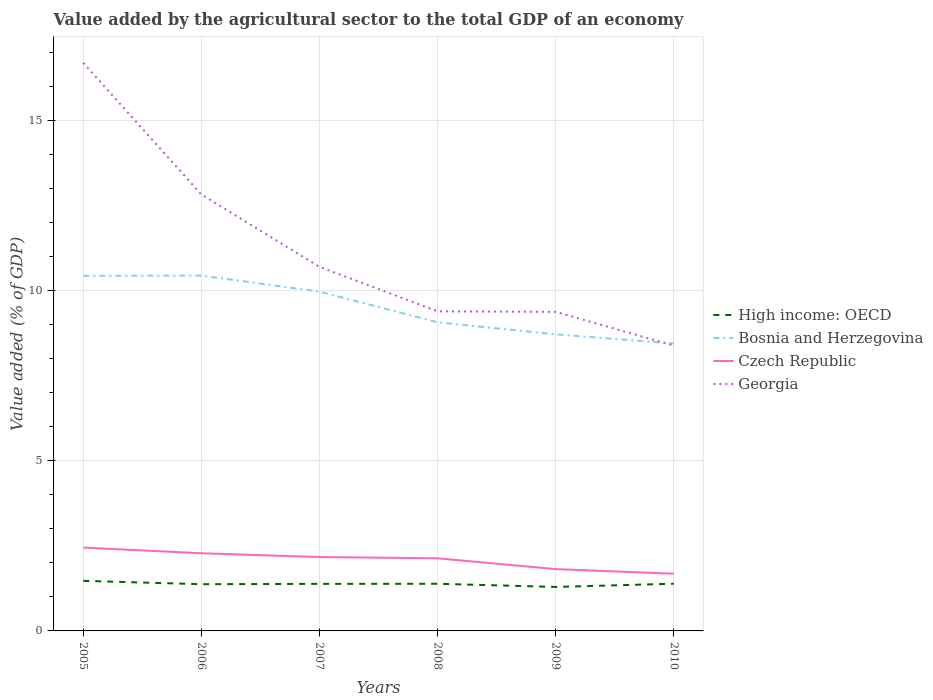Is the number of lines equal to the number of legend labels?
Offer a very short reply. Yes. Across all years, what is the maximum value added by the agricultural sector to the total GDP in Bosnia and Herzegovina?
Offer a terse response. 8.44. What is the total value added by the agricultural sector to the total GDP in Bosnia and Herzegovina in the graph?
Your answer should be compact. 1.72. What is the difference between the highest and the second highest value added by the agricultural sector to the total GDP in High income: OECD?
Your answer should be compact. 0.18. What is the difference between the highest and the lowest value added by the agricultural sector to the total GDP in Czech Republic?
Your answer should be compact. 4. Is the value added by the agricultural sector to the total GDP in Bosnia and Herzegovina strictly greater than the value added by the agricultural sector to the total GDP in Czech Republic over the years?
Your response must be concise. No. How many lines are there?
Provide a succinct answer. 4. What is the difference between two consecutive major ticks on the Y-axis?
Provide a short and direct response. 5. Does the graph contain any zero values?
Your answer should be compact. No. Where does the legend appear in the graph?
Your answer should be very brief. Center right. How many legend labels are there?
Your answer should be very brief. 4. What is the title of the graph?
Ensure brevity in your answer.  Value added by the agricultural sector to the total GDP of an economy. Does "Macedonia" appear as one of the legend labels in the graph?
Ensure brevity in your answer.  No. What is the label or title of the X-axis?
Make the answer very short. Years. What is the label or title of the Y-axis?
Provide a short and direct response. Value added (% of GDP). What is the Value added (% of GDP) in High income: OECD in 2005?
Your response must be concise. 1.47. What is the Value added (% of GDP) of Bosnia and Herzegovina in 2005?
Ensure brevity in your answer.  10.43. What is the Value added (% of GDP) of Czech Republic in 2005?
Your response must be concise. 2.45. What is the Value added (% of GDP) of Georgia in 2005?
Provide a succinct answer. 16.69. What is the Value added (% of GDP) in High income: OECD in 2006?
Your answer should be very brief. 1.37. What is the Value added (% of GDP) of Bosnia and Herzegovina in 2006?
Keep it short and to the point. 10.44. What is the Value added (% of GDP) of Czech Republic in 2006?
Your response must be concise. 2.28. What is the Value added (% of GDP) of Georgia in 2006?
Your answer should be compact. 12.82. What is the Value added (% of GDP) in High income: OECD in 2007?
Keep it short and to the point. 1.38. What is the Value added (% of GDP) in Bosnia and Herzegovina in 2007?
Ensure brevity in your answer.  9.97. What is the Value added (% of GDP) of Czech Republic in 2007?
Offer a terse response. 2.17. What is the Value added (% of GDP) in Georgia in 2007?
Provide a short and direct response. 10.7. What is the Value added (% of GDP) in High income: OECD in 2008?
Offer a terse response. 1.39. What is the Value added (% of GDP) of Bosnia and Herzegovina in 2008?
Provide a succinct answer. 9.07. What is the Value added (% of GDP) in Czech Republic in 2008?
Ensure brevity in your answer.  2.13. What is the Value added (% of GDP) of Georgia in 2008?
Provide a short and direct response. 9.39. What is the Value added (% of GDP) in High income: OECD in 2009?
Keep it short and to the point. 1.29. What is the Value added (% of GDP) of Bosnia and Herzegovina in 2009?
Your answer should be compact. 8.71. What is the Value added (% of GDP) of Czech Republic in 2009?
Offer a very short reply. 1.82. What is the Value added (% of GDP) of Georgia in 2009?
Offer a terse response. 9.37. What is the Value added (% of GDP) of High income: OECD in 2010?
Your answer should be very brief. 1.39. What is the Value added (% of GDP) of Bosnia and Herzegovina in 2010?
Your answer should be compact. 8.44. What is the Value added (% of GDP) of Czech Republic in 2010?
Your response must be concise. 1.68. What is the Value added (% of GDP) of Georgia in 2010?
Offer a terse response. 8.38. Across all years, what is the maximum Value added (% of GDP) in High income: OECD?
Ensure brevity in your answer.  1.47. Across all years, what is the maximum Value added (% of GDP) in Bosnia and Herzegovina?
Keep it short and to the point. 10.44. Across all years, what is the maximum Value added (% of GDP) of Czech Republic?
Offer a terse response. 2.45. Across all years, what is the maximum Value added (% of GDP) in Georgia?
Keep it short and to the point. 16.69. Across all years, what is the minimum Value added (% of GDP) of High income: OECD?
Your answer should be very brief. 1.29. Across all years, what is the minimum Value added (% of GDP) in Bosnia and Herzegovina?
Your answer should be compact. 8.44. Across all years, what is the minimum Value added (% of GDP) in Czech Republic?
Your answer should be compact. 1.68. Across all years, what is the minimum Value added (% of GDP) of Georgia?
Offer a terse response. 8.38. What is the total Value added (% of GDP) of High income: OECD in the graph?
Provide a short and direct response. 8.29. What is the total Value added (% of GDP) of Bosnia and Herzegovina in the graph?
Make the answer very short. 57.06. What is the total Value added (% of GDP) in Czech Republic in the graph?
Ensure brevity in your answer.  12.53. What is the total Value added (% of GDP) in Georgia in the graph?
Provide a succinct answer. 67.35. What is the difference between the Value added (% of GDP) in High income: OECD in 2005 and that in 2006?
Offer a very short reply. 0.1. What is the difference between the Value added (% of GDP) in Bosnia and Herzegovina in 2005 and that in 2006?
Make the answer very short. -0.01. What is the difference between the Value added (% of GDP) of Czech Republic in 2005 and that in 2006?
Your answer should be very brief. 0.17. What is the difference between the Value added (% of GDP) of Georgia in 2005 and that in 2006?
Your response must be concise. 3.87. What is the difference between the Value added (% of GDP) of High income: OECD in 2005 and that in 2007?
Provide a short and direct response. 0.09. What is the difference between the Value added (% of GDP) of Bosnia and Herzegovina in 2005 and that in 2007?
Offer a very short reply. 0.46. What is the difference between the Value added (% of GDP) in Czech Republic in 2005 and that in 2007?
Give a very brief answer. 0.28. What is the difference between the Value added (% of GDP) of Georgia in 2005 and that in 2007?
Ensure brevity in your answer.  5.99. What is the difference between the Value added (% of GDP) of High income: OECD in 2005 and that in 2008?
Your answer should be compact. 0.09. What is the difference between the Value added (% of GDP) of Bosnia and Herzegovina in 2005 and that in 2008?
Provide a succinct answer. 1.36. What is the difference between the Value added (% of GDP) of Czech Republic in 2005 and that in 2008?
Your answer should be very brief. 0.31. What is the difference between the Value added (% of GDP) of Georgia in 2005 and that in 2008?
Ensure brevity in your answer.  7.3. What is the difference between the Value added (% of GDP) in High income: OECD in 2005 and that in 2009?
Offer a terse response. 0.18. What is the difference between the Value added (% of GDP) in Bosnia and Herzegovina in 2005 and that in 2009?
Provide a succinct answer. 1.72. What is the difference between the Value added (% of GDP) of Czech Republic in 2005 and that in 2009?
Keep it short and to the point. 0.63. What is the difference between the Value added (% of GDP) of Georgia in 2005 and that in 2009?
Make the answer very short. 7.32. What is the difference between the Value added (% of GDP) of High income: OECD in 2005 and that in 2010?
Keep it short and to the point. 0.08. What is the difference between the Value added (% of GDP) of Bosnia and Herzegovina in 2005 and that in 2010?
Make the answer very short. 1.99. What is the difference between the Value added (% of GDP) of Czech Republic in 2005 and that in 2010?
Offer a very short reply. 0.77. What is the difference between the Value added (% of GDP) of Georgia in 2005 and that in 2010?
Make the answer very short. 8.31. What is the difference between the Value added (% of GDP) in High income: OECD in 2006 and that in 2007?
Make the answer very short. -0.01. What is the difference between the Value added (% of GDP) in Bosnia and Herzegovina in 2006 and that in 2007?
Offer a terse response. 0.47. What is the difference between the Value added (% of GDP) in Czech Republic in 2006 and that in 2007?
Ensure brevity in your answer.  0.11. What is the difference between the Value added (% of GDP) in Georgia in 2006 and that in 2007?
Make the answer very short. 2.12. What is the difference between the Value added (% of GDP) of High income: OECD in 2006 and that in 2008?
Provide a succinct answer. -0.01. What is the difference between the Value added (% of GDP) in Bosnia and Herzegovina in 2006 and that in 2008?
Keep it short and to the point. 1.37. What is the difference between the Value added (% of GDP) in Czech Republic in 2006 and that in 2008?
Keep it short and to the point. 0.15. What is the difference between the Value added (% of GDP) of Georgia in 2006 and that in 2008?
Your answer should be compact. 3.43. What is the difference between the Value added (% of GDP) in High income: OECD in 2006 and that in 2009?
Provide a short and direct response. 0.08. What is the difference between the Value added (% of GDP) in Bosnia and Herzegovina in 2006 and that in 2009?
Ensure brevity in your answer.  1.73. What is the difference between the Value added (% of GDP) of Czech Republic in 2006 and that in 2009?
Your answer should be very brief. 0.47. What is the difference between the Value added (% of GDP) in Georgia in 2006 and that in 2009?
Your response must be concise. 3.45. What is the difference between the Value added (% of GDP) in High income: OECD in 2006 and that in 2010?
Provide a succinct answer. -0.01. What is the difference between the Value added (% of GDP) of Bosnia and Herzegovina in 2006 and that in 2010?
Your response must be concise. 2. What is the difference between the Value added (% of GDP) of Czech Republic in 2006 and that in 2010?
Keep it short and to the point. 0.6. What is the difference between the Value added (% of GDP) of Georgia in 2006 and that in 2010?
Your answer should be very brief. 4.44. What is the difference between the Value added (% of GDP) in High income: OECD in 2007 and that in 2008?
Make the answer very short. -0. What is the difference between the Value added (% of GDP) in Bosnia and Herzegovina in 2007 and that in 2008?
Your response must be concise. 0.9. What is the difference between the Value added (% of GDP) of Czech Republic in 2007 and that in 2008?
Your answer should be very brief. 0.04. What is the difference between the Value added (% of GDP) of Georgia in 2007 and that in 2008?
Provide a short and direct response. 1.31. What is the difference between the Value added (% of GDP) of High income: OECD in 2007 and that in 2009?
Provide a succinct answer. 0.09. What is the difference between the Value added (% of GDP) in Bosnia and Herzegovina in 2007 and that in 2009?
Keep it short and to the point. 1.26. What is the difference between the Value added (% of GDP) of Czech Republic in 2007 and that in 2009?
Make the answer very short. 0.35. What is the difference between the Value added (% of GDP) of Georgia in 2007 and that in 2009?
Make the answer very short. 1.32. What is the difference between the Value added (% of GDP) in High income: OECD in 2007 and that in 2010?
Your answer should be very brief. -0. What is the difference between the Value added (% of GDP) of Bosnia and Herzegovina in 2007 and that in 2010?
Offer a very short reply. 1.52. What is the difference between the Value added (% of GDP) of Czech Republic in 2007 and that in 2010?
Your answer should be very brief. 0.49. What is the difference between the Value added (% of GDP) in Georgia in 2007 and that in 2010?
Offer a very short reply. 2.31. What is the difference between the Value added (% of GDP) of High income: OECD in 2008 and that in 2009?
Give a very brief answer. 0.09. What is the difference between the Value added (% of GDP) in Bosnia and Herzegovina in 2008 and that in 2009?
Your answer should be compact. 0.35. What is the difference between the Value added (% of GDP) of Czech Republic in 2008 and that in 2009?
Keep it short and to the point. 0.32. What is the difference between the Value added (% of GDP) of Georgia in 2008 and that in 2009?
Offer a very short reply. 0.02. What is the difference between the Value added (% of GDP) in High income: OECD in 2008 and that in 2010?
Provide a succinct answer. -0. What is the difference between the Value added (% of GDP) of Bosnia and Herzegovina in 2008 and that in 2010?
Provide a succinct answer. 0.62. What is the difference between the Value added (% of GDP) of Czech Republic in 2008 and that in 2010?
Provide a short and direct response. 0.45. What is the difference between the Value added (% of GDP) in High income: OECD in 2009 and that in 2010?
Your answer should be very brief. -0.09. What is the difference between the Value added (% of GDP) in Bosnia and Herzegovina in 2009 and that in 2010?
Your response must be concise. 0.27. What is the difference between the Value added (% of GDP) of Czech Republic in 2009 and that in 2010?
Ensure brevity in your answer.  0.14. What is the difference between the Value added (% of GDP) in Georgia in 2009 and that in 2010?
Ensure brevity in your answer.  0.99. What is the difference between the Value added (% of GDP) in High income: OECD in 2005 and the Value added (% of GDP) in Bosnia and Herzegovina in 2006?
Your answer should be very brief. -8.97. What is the difference between the Value added (% of GDP) in High income: OECD in 2005 and the Value added (% of GDP) in Czech Republic in 2006?
Ensure brevity in your answer.  -0.81. What is the difference between the Value added (% of GDP) of High income: OECD in 2005 and the Value added (% of GDP) of Georgia in 2006?
Provide a short and direct response. -11.35. What is the difference between the Value added (% of GDP) in Bosnia and Herzegovina in 2005 and the Value added (% of GDP) in Czech Republic in 2006?
Make the answer very short. 8.15. What is the difference between the Value added (% of GDP) of Bosnia and Herzegovina in 2005 and the Value added (% of GDP) of Georgia in 2006?
Offer a terse response. -2.39. What is the difference between the Value added (% of GDP) of Czech Republic in 2005 and the Value added (% of GDP) of Georgia in 2006?
Give a very brief answer. -10.37. What is the difference between the Value added (% of GDP) in High income: OECD in 2005 and the Value added (% of GDP) in Bosnia and Herzegovina in 2007?
Your answer should be compact. -8.5. What is the difference between the Value added (% of GDP) in High income: OECD in 2005 and the Value added (% of GDP) in Czech Republic in 2007?
Offer a very short reply. -0.7. What is the difference between the Value added (% of GDP) in High income: OECD in 2005 and the Value added (% of GDP) in Georgia in 2007?
Provide a short and direct response. -9.22. What is the difference between the Value added (% of GDP) of Bosnia and Herzegovina in 2005 and the Value added (% of GDP) of Czech Republic in 2007?
Keep it short and to the point. 8.26. What is the difference between the Value added (% of GDP) of Bosnia and Herzegovina in 2005 and the Value added (% of GDP) of Georgia in 2007?
Provide a succinct answer. -0.26. What is the difference between the Value added (% of GDP) of Czech Republic in 2005 and the Value added (% of GDP) of Georgia in 2007?
Provide a succinct answer. -8.25. What is the difference between the Value added (% of GDP) in High income: OECD in 2005 and the Value added (% of GDP) in Bosnia and Herzegovina in 2008?
Offer a very short reply. -7.59. What is the difference between the Value added (% of GDP) in High income: OECD in 2005 and the Value added (% of GDP) in Czech Republic in 2008?
Keep it short and to the point. -0.66. What is the difference between the Value added (% of GDP) of High income: OECD in 2005 and the Value added (% of GDP) of Georgia in 2008?
Your answer should be compact. -7.92. What is the difference between the Value added (% of GDP) of Bosnia and Herzegovina in 2005 and the Value added (% of GDP) of Czech Republic in 2008?
Provide a short and direct response. 8.3. What is the difference between the Value added (% of GDP) of Bosnia and Herzegovina in 2005 and the Value added (% of GDP) of Georgia in 2008?
Your answer should be very brief. 1.04. What is the difference between the Value added (% of GDP) of Czech Republic in 2005 and the Value added (% of GDP) of Georgia in 2008?
Your answer should be very brief. -6.94. What is the difference between the Value added (% of GDP) of High income: OECD in 2005 and the Value added (% of GDP) of Bosnia and Herzegovina in 2009?
Your answer should be compact. -7.24. What is the difference between the Value added (% of GDP) in High income: OECD in 2005 and the Value added (% of GDP) in Czech Republic in 2009?
Offer a very short reply. -0.34. What is the difference between the Value added (% of GDP) of High income: OECD in 2005 and the Value added (% of GDP) of Georgia in 2009?
Offer a very short reply. -7.9. What is the difference between the Value added (% of GDP) in Bosnia and Herzegovina in 2005 and the Value added (% of GDP) in Czech Republic in 2009?
Your response must be concise. 8.61. What is the difference between the Value added (% of GDP) of Bosnia and Herzegovina in 2005 and the Value added (% of GDP) of Georgia in 2009?
Provide a short and direct response. 1.06. What is the difference between the Value added (% of GDP) of Czech Republic in 2005 and the Value added (% of GDP) of Georgia in 2009?
Offer a terse response. -6.92. What is the difference between the Value added (% of GDP) in High income: OECD in 2005 and the Value added (% of GDP) in Bosnia and Herzegovina in 2010?
Your answer should be compact. -6.97. What is the difference between the Value added (% of GDP) in High income: OECD in 2005 and the Value added (% of GDP) in Czech Republic in 2010?
Provide a succinct answer. -0.21. What is the difference between the Value added (% of GDP) of High income: OECD in 2005 and the Value added (% of GDP) of Georgia in 2010?
Offer a very short reply. -6.91. What is the difference between the Value added (% of GDP) of Bosnia and Herzegovina in 2005 and the Value added (% of GDP) of Czech Republic in 2010?
Your answer should be compact. 8.75. What is the difference between the Value added (% of GDP) in Bosnia and Herzegovina in 2005 and the Value added (% of GDP) in Georgia in 2010?
Ensure brevity in your answer.  2.05. What is the difference between the Value added (% of GDP) in Czech Republic in 2005 and the Value added (% of GDP) in Georgia in 2010?
Ensure brevity in your answer.  -5.93. What is the difference between the Value added (% of GDP) of High income: OECD in 2006 and the Value added (% of GDP) of Bosnia and Herzegovina in 2007?
Your answer should be very brief. -8.59. What is the difference between the Value added (% of GDP) of High income: OECD in 2006 and the Value added (% of GDP) of Czech Republic in 2007?
Offer a terse response. -0.8. What is the difference between the Value added (% of GDP) in High income: OECD in 2006 and the Value added (% of GDP) in Georgia in 2007?
Your answer should be very brief. -9.32. What is the difference between the Value added (% of GDP) of Bosnia and Herzegovina in 2006 and the Value added (% of GDP) of Czech Republic in 2007?
Offer a terse response. 8.27. What is the difference between the Value added (% of GDP) of Bosnia and Herzegovina in 2006 and the Value added (% of GDP) of Georgia in 2007?
Ensure brevity in your answer.  -0.26. What is the difference between the Value added (% of GDP) in Czech Republic in 2006 and the Value added (% of GDP) in Georgia in 2007?
Offer a very short reply. -8.41. What is the difference between the Value added (% of GDP) of High income: OECD in 2006 and the Value added (% of GDP) of Bosnia and Herzegovina in 2008?
Offer a very short reply. -7.69. What is the difference between the Value added (% of GDP) of High income: OECD in 2006 and the Value added (% of GDP) of Czech Republic in 2008?
Make the answer very short. -0.76. What is the difference between the Value added (% of GDP) of High income: OECD in 2006 and the Value added (% of GDP) of Georgia in 2008?
Provide a short and direct response. -8.02. What is the difference between the Value added (% of GDP) of Bosnia and Herzegovina in 2006 and the Value added (% of GDP) of Czech Republic in 2008?
Offer a terse response. 8.31. What is the difference between the Value added (% of GDP) in Bosnia and Herzegovina in 2006 and the Value added (% of GDP) in Georgia in 2008?
Give a very brief answer. 1.05. What is the difference between the Value added (% of GDP) in Czech Republic in 2006 and the Value added (% of GDP) in Georgia in 2008?
Make the answer very short. -7.11. What is the difference between the Value added (% of GDP) of High income: OECD in 2006 and the Value added (% of GDP) of Bosnia and Herzegovina in 2009?
Your answer should be compact. -7.34. What is the difference between the Value added (% of GDP) in High income: OECD in 2006 and the Value added (% of GDP) in Czech Republic in 2009?
Offer a very short reply. -0.44. What is the difference between the Value added (% of GDP) of High income: OECD in 2006 and the Value added (% of GDP) of Georgia in 2009?
Make the answer very short. -8. What is the difference between the Value added (% of GDP) of Bosnia and Herzegovina in 2006 and the Value added (% of GDP) of Czech Republic in 2009?
Your response must be concise. 8.62. What is the difference between the Value added (% of GDP) in Bosnia and Herzegovina in 2006 and the Value added (% of GDP) in Georgia in 2009?
Your answer should be very brief. 1.07. What is the difference between the Value added (% of GDP) in Czech Republic in 2006 and the Value added (% of GDP) in Georgia in 2009?
Your response must be concise. -7.09. What is the difference between the Value added (% of GDP) in High income: OECD in 2006 and the Value added (% of GDP) in Bosnia and Herzegovina in 2010?
Your response must be concise. -7.07. What is the difference between the Value added (% of GDP) of High income: OECD in 2006 and the Value added (% of GDP) of Czech Republic in 2010?
Ensure brevity in your answer.  -0.31. What is the difference between the Value added (% of GDP) of High income: OECD in 2006 and the Value added (% of GDP) of Georgia in 2010?
Give a very brief answer. -7.01. What is the difference between the Value added (% of GDP) in Bosnia and Herzegovina in 2006 and the Value added (% of GDP) in Czech Republic in 2010?
Ensure brevity in your answer.  8.76. What is the difference between the Value added (% of GDP) in Bosnia and Herzegovina in 2006 and the Value added (% of GDP) in Georgia in 2010?
Ensure brevity in your answer.  2.06. What is the difference between the Value added (% of GDP) of Czech Republic in 2006 and the Value added (% of GDP) of Georgia in 2010?
Provide a short and direct response. -6.1. What is the difference between the Value added (% of GDP) of High income: OECD in 2007 and the Value added (% of GDP) of Bosnia and Herzegovina in 2008?
Provide a short and direct response. -7.68. What is the difference between the Value added (% of GDP) of High income: OECD in 2007 and the Value added (% of GDP) of Czech Republic in 2008?
Provide a succinct answer. -0.75. What is the difference between the Value added (% of GDP) of High income: OECD in 2007 and the Value added (% of GDP) of Georgia in 2008?
Your answer should be very brief. -8.01. What is the difference between the Value added (% of GDP) of Bosnia and Herzegovina in 2007 and the Value added (% of GDP) of Czech Republic in 2008?
Offer a very short reply. 7.83. What is the difference between the Value added (% of GDP) of Bosnia and Herzegovina in 2007 and the Value added (% of GDP) of Georgia in 2008?
Your answer should be compact. 0.58. What is the difference between the Value added (% of GDP) in Czech Republic in 2007 and the Value added (% of GDP) in Georgia in 2008?
Provide a short and direct response. -7.22. What is the difference between the Value added (% of GDP) of High income: OECD in 2007 and the Value added (% of GDP) of Bosnia and Herzegovina in 2009?
Ensure brevity in your answer.  -7.33. What is the difference between the Value added (% of GDP) in High income: OECD in 2007 and the Value added (% of GDP) in Czech Republic in 2009?
Your response must be concise. -0.43. What is the difference between the Value added (% of GDP) in High income: OECD in 2007 and the Value added (% of GDP) in Georgia in 2009?
Offer a very short reply. -7.99. What is the difference between the Value added (% of GDP) in Bosnia and Herzegovina in 2007 and the Value added (% of GDP) in Czech Republic in 2009?
Ensure brevity in your answer.  8.15. What is the difference between the Value added (% of GDP) of Bosnia and Herzegovina in 2007 and the Value added (% of GDP) of Georgia in 2009?
Make the answer very short. 0.59. What is the difference between the Value added (% of GDP) in Czech Republic in 2007 and the Value added (% of GDP) in Georgia in 2009?
Offer a terse response. -7.2. What is the difference between the Value added (% of GDP) of High income: OECD in 2007 and the Value added (% of GDP) of Bosnia and Herzegovina in 2010?
Make the answer very short. -7.06. What is the difference between the Value added (% of GDP) of High income: OECD in 2007 and the Value added (% of GDP) of Czech Republic in 2010?
Provide a short and direct response. -0.3. What is the difference between the Value added (% of GDP) in High income: OECD in 2007 and the Value added (% of GDP) in Georgia in 2010?
Your answer should be compact. -7. What is the difference between the Value added (% of GDP) of Bosnia and Herzegovina in 2007 and the Value added (% of GDP) of Czech Republic in 2010?
Make the answer very short. 8.29. What is the difference between the Value added (% of GDP) in Bosnia and Herzegovina in 2007 and the Value added (% of GDP) in Georgia in 2010?
Provide a succinct answer. 1.59. What is the difference between the Value added (% of GDP) of Czech Republic in 2007 and the Value added (% of GDP) of Georgia in 2010?
Make the answer very short. -6.21. What is the difference between the Value added (% of GDP) of High income: OECD in 2008 and the Value added (% of GDP) of Bosnia and Herzegovina in 2009?
Make the answer very short. -7.33. What is the difference between the Value added (% of GDP) in High income: OECD in 2008 and the Value added (% of GDP) in Czech Republic in 2009?
Ensure brevity in your answer.  -0.43. What is the difference between the Value added (% of GDP) of High income: OECD in 2008 and the Value added (% of GDP) of Georgia in 2009?
Your answer should be compact. -7.99. What is the difference between the Value added (% of GDP) of Bosnia and Herzegovina in 2008 and the Value added (% of GDP) of Czech Republic in 2009?
Offer a very short reply. 7.25. What is the difference between the Value added (% of GDP) of Bosnia and Herzegovina in 2008 and the Value added (% of GDP) of Georgia in 2009?
Provide a succinct answer. -0.31. What is the difference between the Value added (% of GDP) in Czech Republic in 2008 and the Value added (% of GDP) in Georgia in 2009?
Keep it short and to the point. -7.24. What is the difference between the Value added (% of GDP) in High income: OECD in 2008 and the Value added (% of GDP) in Bosnia and Herzegovina in 2010?
Offer a very short reply. -7.06. What is the difference between the Value added (% of GDP) in High income: OECD in 2008 and the Value added (% of GDP) in Czech Republic in 2010?
Provide a succinct answer. -0.3. What is the difference between the Value added (% of GDP) of High income: OECD in 2008 and the Value added (% of GDP) of Georgia in 2010?
Give a very brief answer. -7. What is the difference between the Value added (% of GDP) in Bosnia and Herzegovina in 2008 and the Value added (% of GDP) in Czech Republic in 2010?
Provide a short and direct response. 7.39. What is the difference between the Value added (% of GDP) of Bosnia and Herzegovina in 2008 and the Value added (% of GDP) of Georgia in 2010?
Offer a very short reply. 0.68. What is the difference between the Value added (% of GDP) of Czech Republic in 2008 and the Value added (% of GDP) of Georgia in 2010?
Your response must be concise. -6.25. What is the difference between the Value added (% of GDP) in High income: OECD in 2009 and the Value added (% of GDP) in Bosnia and Herzegovina in 2010?
Your response must be concise. -7.15. What is the difference between the Value added (% of GDP) in High income: OECD in 2009 and the Value added (% of GDP) in Czech Republic in 2010?
Make the answer very short. -0.39. What is the difference between the Value added (% of GDP) in High income: OECD in 2009 and the Value added (% of GDP) in Georgia in 2010?
Your answer should be compact. -7.09. What is the difference between the Value added (% of GDP) of Bosnia and Herzegovina in 2009 and the Value added (% of GDP) of Czech Republic in 2010?
Your answer should be compact. 7.03. What is the difference between the Value added (% of GDP) in Bosnia and Herzegovina in 2009 and the Value added (% of GDP) in Georgia in 2010?
Your answer should be compact. 0.33. What is the difference between the Value added (% of GDP) in Czech Republic in 2009 and the Value added (% of GDP) in Georgia in 2010?
Provide a short and direct response. -6.57. What is the average Value added (% of GDP) in High income: OECD per year?
Offer a terse response. 1.38. What is the average Value added (% of GDP) in Bosnia and Herzegovina per year?
Offer a very short reply. 9.51. What is the average Value added (% of GDP) of Czech Republic per year?
Your response must be concise. 2.09. What is the average Value added (% of GDP) in Georgia per year?
Your answer should be compact. 11.22. In the year 2005, what is the difference between the Value added (% of GDP) in High income: OECD and Value added (% of GDP) in Bosnia and Herzegovina?
Your answer should be very brief. -8.96. In the year 2005, what is the difference between the Value added (% of GDP) in High income: OECD and Value added (% of GDP) in Czech Republic?
Provide a short and direct response. -0.98. In the year 2005, what is the difference between the Value added (% of GDP) in High income: OECD and Value added (% of GDP) in Georgia?
Offer a terse response. -15.22. In the year 2005, what is the difference between the Value added (% of GDP) in Bosnia and Herzegovina and Value added (% of GDP) in Czech Republic?
Provide a succinct answer. 7.98. In the year 2005, what is the difference between the Value added (% of GDP) of Bosnia and Herzegovina and Value added (% of GDP) of Georgia?
Ensure brevity in your answer.  -6.26. In the year 2005, what is the difference between the Value added (% of GDP) in Czech Republic and Value added (% of GDP) in Georgia?
Your answer should be very brief. -14.24. In the year 2006, what is the difference between the Value added (% of GDP) of High income: OECD and Value added (% of GDP) of Bosnia and Herzegovina?
Give a very brief answer. -9.07. In the year 2006, what is the difference between the Value added (% of GDP) in High income: OECD and Value added (% of GDP) in Czech Republic?
Provide a succinct answer. -0.91. In the year 2006, what is the difference between the Value added (% of GDP) of High income: OECD and Value added (% of GDP) of Georgia?
Offer a very short reply. -11.45. In the year 2006, what is the difference between the Value added (% of GDP) in Bosnia and Herzegovina and Value added (% of GDP) in Czech Republic?
Your answer should be very brief. 8.16. In the year 2006, what is the difference between the Value added (% of GDP) in Bosnia and Herzegovina and Value added (% of GDP) in Georgia?
Ensure brevity in your answer.  -2.38. In the year 2006, what is the difference between the Value added (% of GDP) in Czech Republic and Value added (% of GDP) in Georgia?
Provide a short and direct response. -10.54. In the year 2007, what is the difference between the Value added (% of GDP) in High income: OECD and Value added (% of GDP) in Bosnia and Herzegovina?
Provide a short and direct response. -8.58. In the year 2007, what is the difference between the Value added (% of GDP) in High income: OECD and Value added (% of GDP) in Czech Republic?
Keep it short and to the point. -0.79. In the year 2007, what is the difference between the Value added (% of GDP) of High income: OECD and Value added (% of GDP) of Georgia?
Keep it short and to the point. -9.31. In the year 2007, what is the difference between the Value added (% of GDP) in Bosnia and Herzegovina and Value added (% of GDP) in Czech Republic?
Provide a succinct answer. 7.8. In the year 2007, what is the difference between the Value added (% of GDP) of Bosnia and Herzegovina and Value added (% of GDP) of Georgia?
Ensure brevity in your answer.  -0.73. In the year 2007, what is the difference between the Value added (% of GDP) in Czech Republic and Value added (% of GDP) in Georgia?
Give a very brief answer. -8.53. In the year 2008, what is the difference between the Value added (% of GDP) of High income: OECD and Value added (% of GDP) of Bosnia and Herzegovina?
Provide a short and direct response. -7.68. In the year 2008, what is the difference between the Value added (% of GDP) of High income: OECD and Value added (% of GDP) of Czech Republic?
Your response must be concise. -0.75. In the year 2008, what is the difference between the Value added (% of GDP) in High income: OECD and Value added (% of GDP) in Georgia?
Offer a very short reply. -8. In the year 2008, what is the difference between the Value added (% of GDP) of Bosnia and Herzegovina and Value added (% of GDP) of Czech Republic?
Make the answer very short. 6.93. In the year 2008, what is the difference between the Value added (% of GDP) of Bosnia and Herzegovina and Value added (% of GDP) of Georgia?
Make the answer very short. -0.32. In the year 2008, what is the difference between the Value added (% of GDP) of Czech Republic and Value added (% of GDP) of Georgia?
Your response must be concise. -7.25. In the year 2009, what is the difference between the Value added (% of GDP) of High income: OECD and Value added (% of GDP) of Bosnia and Herzegovina?
Make the answer very short. -7.42. In the year 2009, what is the difference between the Value added (% of GDP) in High income: OECD and Value added (% of GDP) in Czech Republic?
Your response must be concise. -0.52. In the year 2009, what is the difference between the Value added (% of GDP) in High income: OECD and Value added (% of GDP) in Georgia?
Give a very brief answer. -8.08. In the year 2009, what is the difference between the Value added (% of GDP) of Bosnia and Herzegovina and Value added (% of GDP) of Czech Republic?
Your response must be concise. 6.9. In the year 2009, what is the difference between the Value added (% of GDP) of Bosnia and Herzegovina and Value added (% of GDP) of Georgia?
Provide a short and direct response. -0.66. In the year 2009, what is the difference between the Value added (% of GDP) of Czech Republic and Value added (% of GDP) of Georgia?
Make the answer very short. -7.56. In the year 2010, what is the difference between the Value added (% of GDP) of High income: OECD and Value added (% of GDP) of Bosnia and Herzegovina?
Your answer should be very brief. -7.06. In the year 2010, what is the difference between the Value added (% of GDP) in High income: OECD and Value added (% of GDP) in Czech Republic?
Provide a succinct answer. -0.29. In the year 2010, what is the difference between the Value added (% of GDP) in High income: OECD and Value added (% of GDP) in Georgia?
Offer a very short reply. -6.99. In the year 2010, what is the difference between the Value added (% of GDP) of Bosnia and Herzegovina and Value added (% of GDP) of Czech Republic?
Ensure brevity in your answer.  6.76. In the year 2010, what is the difference between the Value added (% of GDP) in Bosnia and Herzegovina and Value added (% of GDP) in Georgia?
Your answer should be very brief. 0.06. In the year 2010, what is the difference between the Value added (% of GDP) in Czech Republic and Value added (% of GDP) in Georgia?
Ensure brevity in your answer.  -6.7. What is the ratio of the Value added (% of GDP) of High income: OECD in 2005 to that in 2006?
Provide a short and direct response. 1.07. What is the ratio of the Value added (% of GDP) in Czech Republic in 2005 to that in 2006?
Provide a short and direct response. 1.07. What is the ratio of the Value added (% of GDP) in Georgia in 2005 to that in 2006?
Your answer should be very brief. 1.3. What is the ratio of the Value added (% of GDP) of High income: OECD in 2005 to that in 2007?
Your response must be concise. 1.06. What is the ratio of the Value added (% of GDP) of Bosnia and Herzegovina in 2005 to that in 2007?
Provide a succinct answer. 1.05. What is the ratio of the Value added (% of GDP) of Czech Republic in 2005 to that in 2007?
Offer a very short reply. 1.13. What is the ratio of the Value added (% of GDP) of Georgia in 2005 to that in 2007?
Your answer should be compact. 1.56. What is the ratio of the Value added (% of GDP) in High income: OECD in 2005 to that in 2008?
Keep it short and to the point. 1.06. What is the ratio of the Value added (% of GDP) of Bosnia and Herzegovina in 2005 to that in 2008?
Ensure brevity in your answer.  1.15. What is the ratio of the Value added (% of GDP) in Czech Republic in 2005 to that in 2008?
Your answer should be very brief. 1.15. What is the ratio of the Value added (% of GDP) of Georgia in 2005 to that in 2008?
Ensure brevity in your answer.  1.78. What is the ratio of the Value added (% of GDP) of High income: OECD in 2005 to that in 2009?
Your answer should be very brief. 1.14. What is the ratio of the Value added (% of GDP) in Bosnia and Herzegovina in 2005 to that in 2009?
Your answer should be very brief. 1.2. What is the ratio of the Value added (% of GDP) of Czech Republic in 2005 to that in 2009?
Your answer should be very brief. 1.35. What is the ratio of the Value added (% of GDP) of Georgia in 2005 to that in 2009?
Your response must be concise. 1.78. What is the ratio of the Value added (% of GDP) in High income: OECD in 2005 to that in 2010?
Provide a short and direct response. 1.06. What is the ratio of the Value added (% of GDP) of Bosnia and Herzegovina in 2005 to that in 2010?
Your answer should be very brief. 1.24. What is the ratio of the Value added (% of GDP) in Czech Republic in 2005 to that in 2010?
Offer a terse response. 1.46. What is the ratio of the Value added (% of GDP) of Georgia in 2005 to that in 2010?
Keep it short and to the point. 1.99. What is the ratio of the Value added (% of GDP) in Bosnia and Herzegovina in 2006 to that in 2007?
Your answer should be compact. 1.05. What is the ratio of the Value added (% of GDP) of Czech Republic in 2006 to that in 2007?
Offer a very short reply. 1.05. What is the ratio of the Value added (% of GDP) of Georgia in 2006 to that in 2007?
Offer a terse response. 1.2. What is the ratio of the Value added (% of GDP) of High income: OECD in 2006 to that in 2008?
Provide a succinct answer. 0.99. What is the ratio of the Value added (% of GDP) in Bosnia and Herzegovina in 2006 to that in 2008?
Your answer should be very brief. 1.15. What is the ratio of the Value added (% of GDP) of Czech Republic in 2006 to that in 2008?
Your answer should be very brief. 1.07. What is the ratio of the Value added (% of GDP) of Georgia in 2006 to that in 2008?
Offer a very short reply. 1.37. What is the ratio of the Value added (% of GDP) in High income: OECD in 2006 to that in 2009?
Your answer should be very brief. 1.06. What is the ratio of the Value added (% of GDP) of Bosnia and Herzegovina in 2006 to that in 2009?
Offer a very short reply. 1.2. What is the ratio of the Value added (% of GDP) in Czech Republic in 2006 to that in 2009?
Provide a short and direct response. 1.26. What is the ratio of the Value added (% of GDP) of Georgia in 2006 to that in 2009?
Make the answer very short. 1.37. What is the ratio of the Value added (% of GDP) in High income: OECD in 2006 to that in 2010?
Your answer should be very brief. 0.99. What is the ratio of the Value added (% of GDP) of Bosnia and Herzegovina in 2006 to that in 2010?
Offer a very short reply. 1.24. What is the ratio of the Value added (% of GDP) in Czech Republic in 2006 to that in 2010?
Offer a very short reply. 1.36. What is the ratio of the Value added (% of GDP) of Georgia in 2006 to that in 2010?
Your answer should be very brief. 1.53. What is the ratio of the Value added (% of GDP) in High income: OECD in 2007 to that in 2008?
Make the answer very short. 1. What is the ratio of the Value added (% of GDP) of Bosnia and Herzegovina in 2007 to that in 2008?
Your response must be concise. 1.1. What is the ratio of the Value added (% of GDP) in Czech Republic in 2007 to that in 2008?
Give a very brief answer. 1.02. What is the ratio of the Value added (% of GDP) of Georgia in 2007 to that in 2008?
Offer a very short reply. 1.14. What is the ratio of the Value added (% of GDP) in High income: OECD in 2007 to that in 2009?
Your response must be concise. 1.07. What is the ratio of the Value added (% of GDP) of Bosnia and Herzegovina in 2007 to that in 2009?
Offer a very short reply. 1.14. What is the ratio of the Value added (% of GDP) in Czech Republic in 2007 to that in 2009?
Keep it short and to the point. 1.2. What is the ratio of the Value added (% of GDP) of Georgia in 2007 to that in 2009?
Your response must be concise. 1.14. What is the ratio of the Value added (% of GDP) in High income: OECD in 2007 to that in 2010?
Your answer should be very brief. 1. What is the ratio of the Value added (% of GDP) of Bosnia and Herzegovina in 2007 to that in 2010?
Your answer should be very brief. 1.18. What is the ratio of the Value added (% of GDP) of Czech Republic in 2007 to that in 2010?
Offer a very short reply. 1.29. What is the ratio of the Value added (% of GDP) of Georgia in 2007 to that in 2010?
Give a very brief answer. 1.28. What is the ratio of the Value added (% of GDP) of High income: OECD in 2008 to that in 2009?
Your answer should be very brief. 1.07. What is the ratio of the Value added (% of GDP) in Bosnia and Herzegovina in 2008 to that in 2009?
Your answer should be very brief. 1.04. What is the ratio of the Value added (% of GDP) of Czech Republic in 2008 to that in 2009?
Provide a short and direct response. 1.17. What is the ratio of the Value added (% of GDP) in Georgia in 2008 to that in 2009?
Your response must be concise. 1. What is the ratio of the Value added (% of GDP) of High income: OECD in 2008 to that in 2010?
Your response must be concise. 1. What is the ratio of the Value added (% of GDP) in Bosnia and Herzegovina in 2008 to that in 2010?
Ensure brevity in your answer.  1.07. What is the ratio of the Value added (% of GDP) of Czech Republic in 2008 to that in 2010?
Make the answer very short. 1.27. What is the ratio of the Value added (% of GDP) of Georgia in 2008 to that in 2010?
Make the answer very short. 1.12. What is the ratio of the Value added (% of GDP) in High income: OECD in 2009 to that in 2010?
Offer a terse response. 0.93. What is the ratio of the Value added (% of GDP) of Bosnia and Herzegovina in 2009 to that in 2010?
Provide a short and direct response. 1.03. What is the ratio of the Value added (% of GDP) of Czech Republic in 2009 to that in 2010?
Make the answer very short. 1.08. What is the ratio of the Value added (% of GDP) of Georgia in 2009 to that in 2010?
Offer a terse response. 1.12. What is the difference between the highest and the second highest Value added (% of GDP) of High income: OECD?
Offer a very short reply. 0.08. What is the difference between the highest and the second highest Value added (% of GDP) in Bosnia and Herzegovina?
Your answer should be very brief. 0.01. What is the difference between the highest and the second highest Value added (% of GDP) of Czech Republic?
Provide a succinct answer. 0.17. What is the difference between the highest and the second highest Value added (% of GDP) in Georgia?
Offer a very short reply. 3.87. What is the difference between the highest and the lowest Value added (% of GDP) in High income: OECD?
Keep it short and to the point. 0.18. What is the difference between the highest and the lowest Value added (% of GDP) of Bosnia and Herzegovina?
Make the answer very short. 2. What is the difference between the highest and the lowest Value added (% of GDP) of Czech Republic?
Offer a terse response. 0.77. What is the difference between the highest and the lowest Value added (% of GDP) of Georgia?
Offer a terse response. 8.31. 